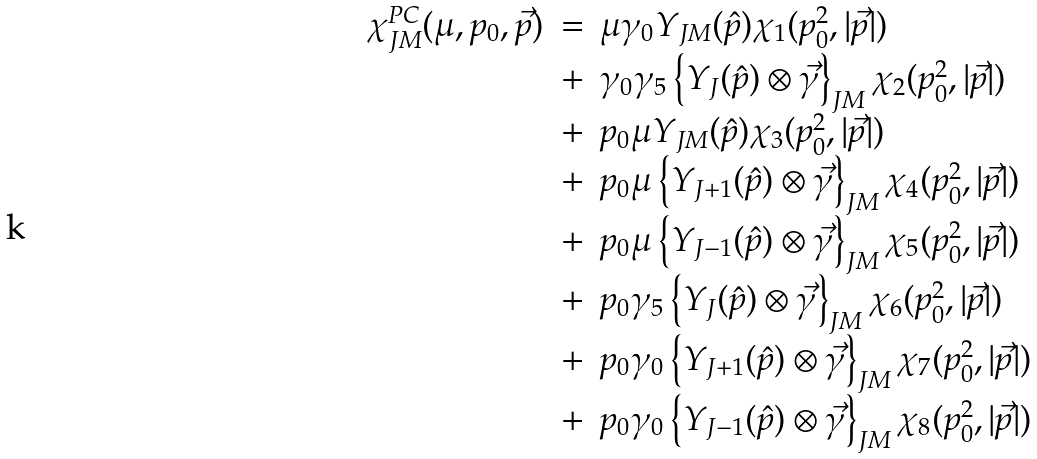<formula> <loc_0><loc_0><loc_500><loc_500>\begin{array} { r c l } \chi _ { J M } ^ { P C } ( \mu , p _ { 0 } , \vec { p } ) & = & \mu \gamma _ { 0 } Y _ { J M } ( \hat { p } ) \chi _ { 1 } ( p _ { 0 } ^ { 2 } , | \vec { p } | ) \\ & + & \gamma _ { 0 } \gamma _ { 5 } \left \{ Y _ { J } ( \hat { p } ) \otimes \vec { \gamma } \right \} _ { J M } \chi _ { 2 } ( p _ { 0 } ^ { 2 } , | \vec { p } | ) \\ & + & p _ { 0 } \mu Y _ { J M } ( \hat { p } ) \chi _ { 3 } ( p _ { 0 } ^ { 2 } , | \vec { p } | ) \\ & + & p _ { 0 } \mu \left \{ Y _ { J + 1 } ( \hat { p } ) \otimes \vec { \gamma } \right \} _ { J M } \chi _ { 4 } ( p _ { 0 } ^ { 2 } , | \vec { p } | ) \\ & + & p _ { 0 } \mu \left \{ Y _ { J - 1 } ( \hat { p } ) \otimes \vec { \gamma } \right \} _ { J M } \chi _ { 5 } ( p _ { 0 } ^ { 2 } , | \vec { p } | ) \\ & + & p _ { 0 } \gamma _ { 5 } \left \{ Y _ { J } ( \hat { p } ) \otimes \vec { \gamma } \right \} _ { J M } \chi _ { 6 } ( p _ { 0 } ^ { 2 } , | \vec { p } | ) \\ & + & p _ { 0 } \gamma _ { 0 } \left \{ Y _ { J + 1 } ( \hat { p } ) \otimes \vec { \gamma } \right \} _ { J M } \chi _ { 7 } ( p _ { 0 } ^ { 2 } , | \vec { p } | ) \\ & + & p _ { 0 } \gamma _ { 0 } \left \{ Y _ { J - 1 } ( \hat { p } ) \otimes \vec { \gamma } \right \} _ { J M } \chi _ { 8 } ( p _ { 0 } ^ { 2 } , | \vec { p } | ) \end{array}</formula> 